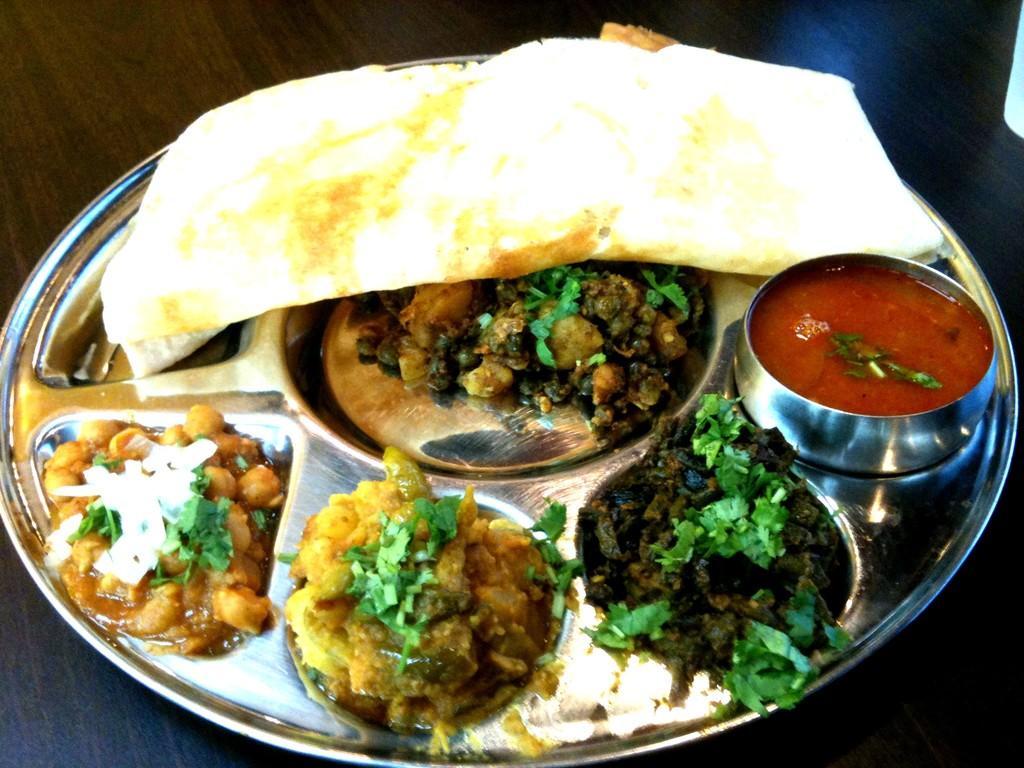How would you summarize this image in a sentence or two? In this image I can see a plate which consists of some different food items. This plate is placed on a table. 